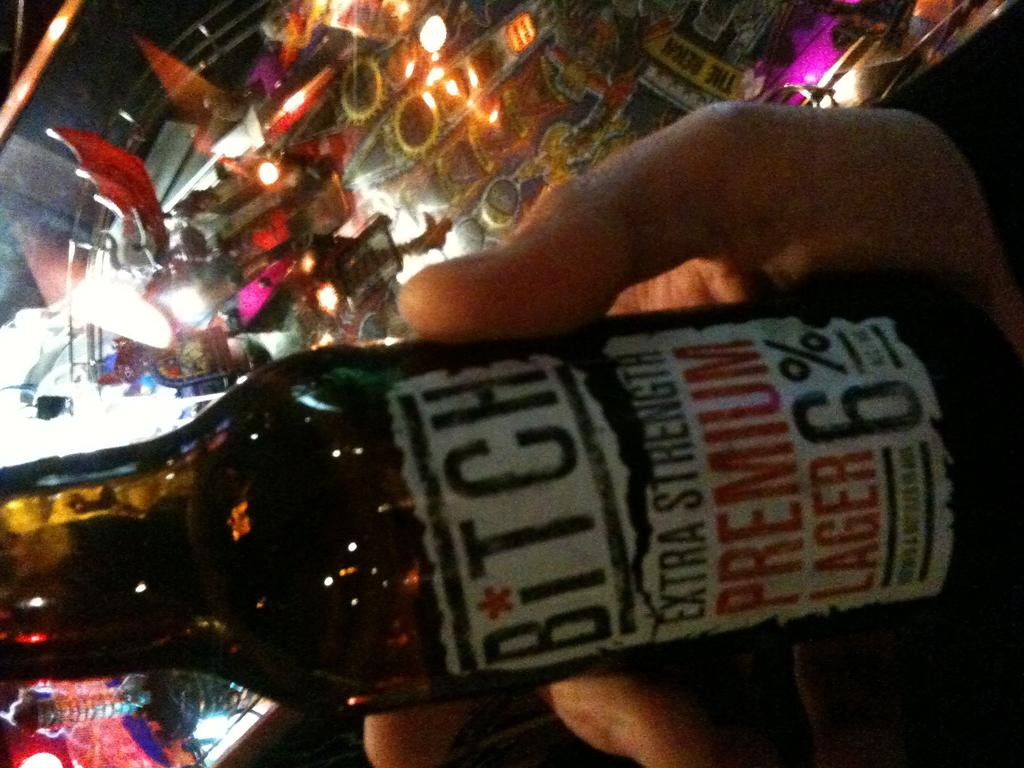<image>
Relay a brief, clear account of the picture shown. Bitch Extra Strength Premium Lager that contains 6% Alcohol by Volume. 